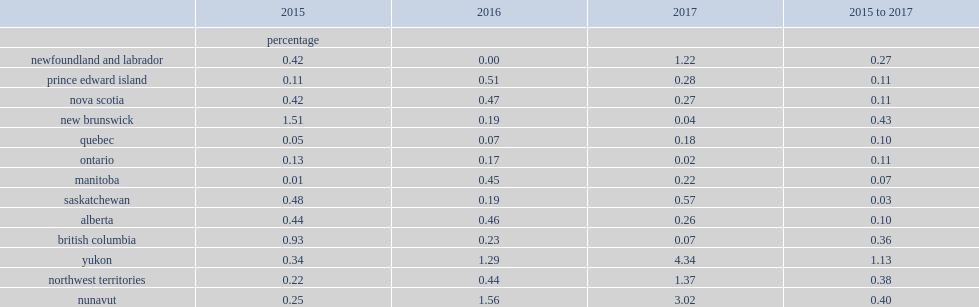What was the range of the mean absolute revision for 2015 to 2017? 0.07 1.13. Which province had the largest absolute mean revision in 2015? Newfoundland and labrador. 